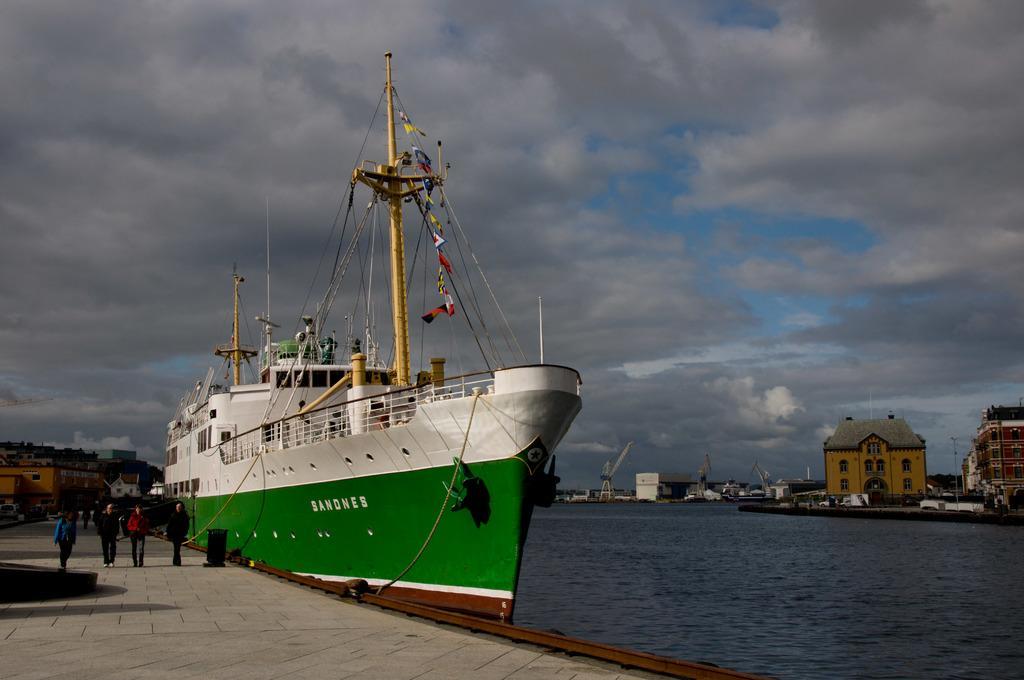Can you describe this image briefly? In this image I can see the ground, few persons standing on the ground, the water, few boats on the surface of the water, few vehicles and few buildings. In the background I can see the sky. 